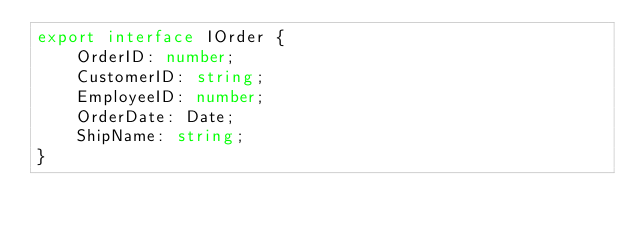<code> <loc_0><loc_0><loc_500><loc_500><_TypeScript_>export interface IOrder {
    OrderID: number;
    CustomerID: string;
    EmployeeID: number;
    OrderDate: Date;
    ShipName: string;
}
</code> 